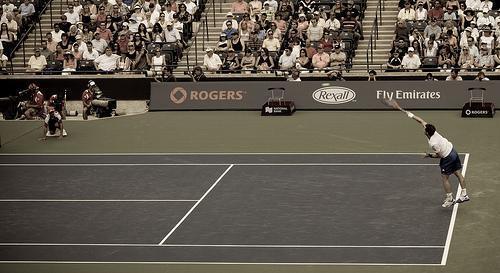How many people are on the tennis court?
Give a very brief answer. 1. 